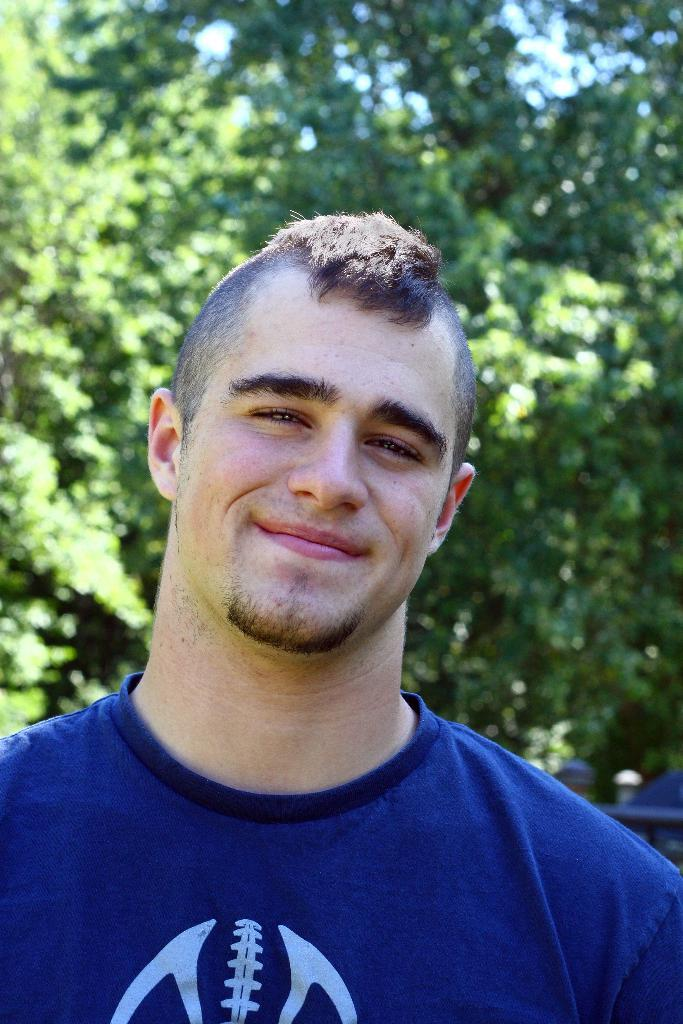Who is present in the image? There is a man in the image. What is the man wearing? The man is wearing a blue t-shirt. What is the man doing in the image? The man is standing and smiling. What can be seen in the background of the image? There are trees visible behind the man. What type of birds can be seen flying over the man's head in the image? There are no birds visible in the image; only the man and trees can be seen. 